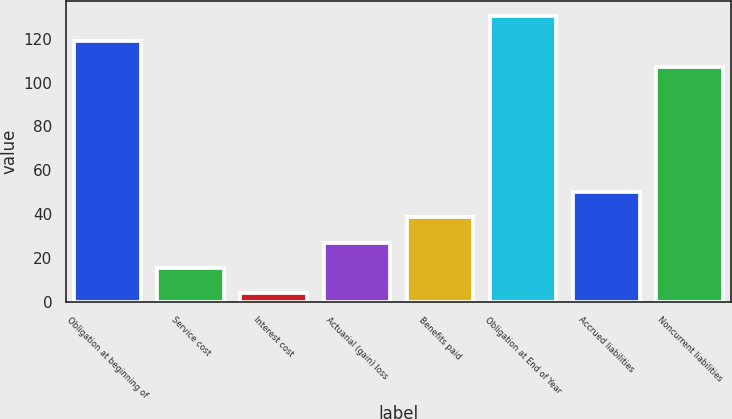<chart> <loc_0><loc_0><loc_500><loc_500><bar_chart><fcel>Obligation at beginning of<fcel>Service cost<fcel>Interest cost<fcel>Actuarial (gain) loss<fcel>Benefits paid<fcel>Obligation at End of Year<fcel>Accrued liabilities<fcel>Noncurrent liabilities<nl><fcel>118.9<fcel>15.5<fcel>3.9<fcel>27.1<fcel>38.7<fcel>130.5<fcel>50.3<fcel>107.3<nl></chart> 